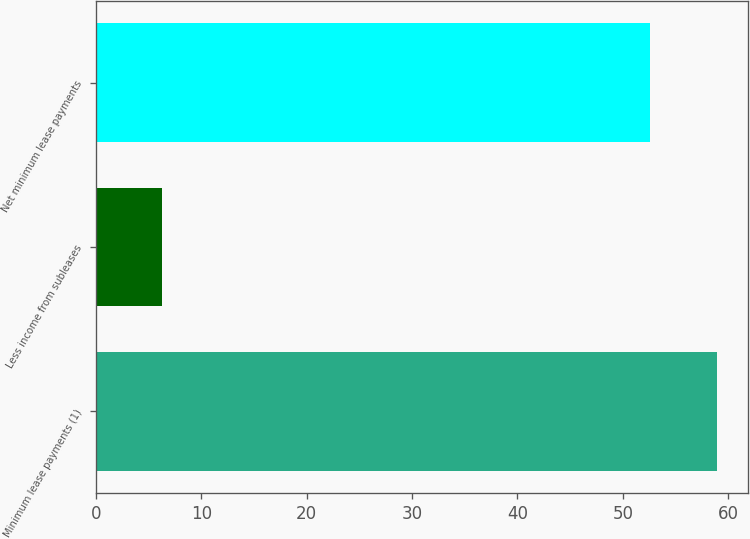Convert chart to OTSL. <chart><loc_0><loc_0><loc_500><loc_500><bar_chart><fcel>Minimum lease payments (1)<fcel>Less income from subleases<fcel>Net minimum lease payments<nl><fcel>58.9<fcel>6.3<fcel>52.6<nl></chart> 